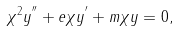Convert formula to latex. <formula><loc_0><loc_0><loc_500><loc_500>\chi ^ { 2 } y ^ { ^ { \prime \prime } } + e \chi y ^ { ^ { \prime } } + m \chi y = 0 ,</formula> 